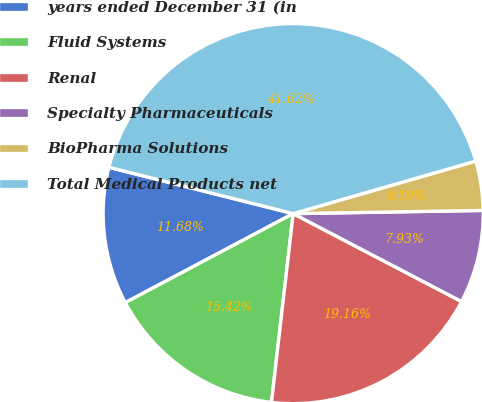Convert chart. <chart><loc_0><loc_0><loc_500><loc_500><pie_chart><fcel>years ended December 31 (in<fcel>Fluid Systems<fcel>Renal<fcel>Specialty Pharmaceuticals<fcel>BioPharma Solutions<fcel>Total Medical Products net<nl><fcel>11.68%<fcel>15.42%<fcel>19.16%<fcel>7.93%<fcel>4.19%<fcel>41.62%<nl></chart> 